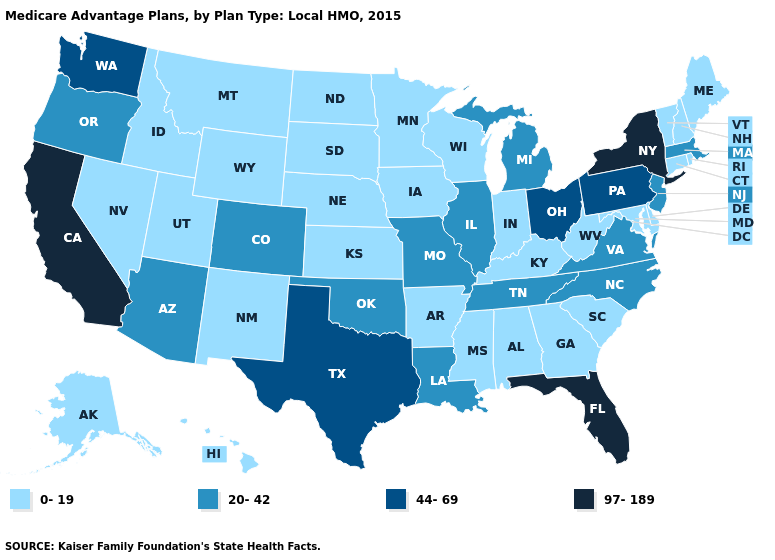Name the states that have a value in the range 0-19?
Answer briefly. Alaska, Alabama, Arkansas, Connecticut, Delaware, Georgia, Hawaii, Iowa, Idaho, Indiana, Kansas, Kentucky, Maryland, Maine, Minnesota, Mississippi, Montana, North Dakota, Nebraska, New Hampshire, New Mexico, Nevada, Rhode Island, South Carolina, South Dakota, Utah, Vermont, Wisconsin, West Virginia, Wyoming. Among the states that border South Carolina , which have the highest value?
Quick response, please. North Carolina. What is the value of Arizona?
Answer briefly. 20-42. Does California have the highest value in the USA?
Quick response, please. Yes. Is the legend a continuous bar?
Give a very brief answer. No. Name the states that have a value in the range 97-189?
Short answer required. California, Florida, New York. Does Alaska have the highest value in the West?
Write a very short answer. No. Does Utah have the highest value in the West?
Keep it brief. No. What is the lowest value in states that border Indiana?
Short answer required. 0-19. Does California have the highest value in the USA?
Be succinct. Yes. Which states have the lowest value in the Northeast?
Short answer required. Connecticut, Maine, New Hampshire, Rhode Island, Vermont. Does North Dakota have the highest value in the MidWest?
Quick response, please. No. Does Maine have the lowest value in the Northeast?
Write a very short answer. Yes. Does Oklahoma have the same value as Arizona?
Short answer required. Yes. What is the lowest value in the West?
Concise answer only. 0-19. 